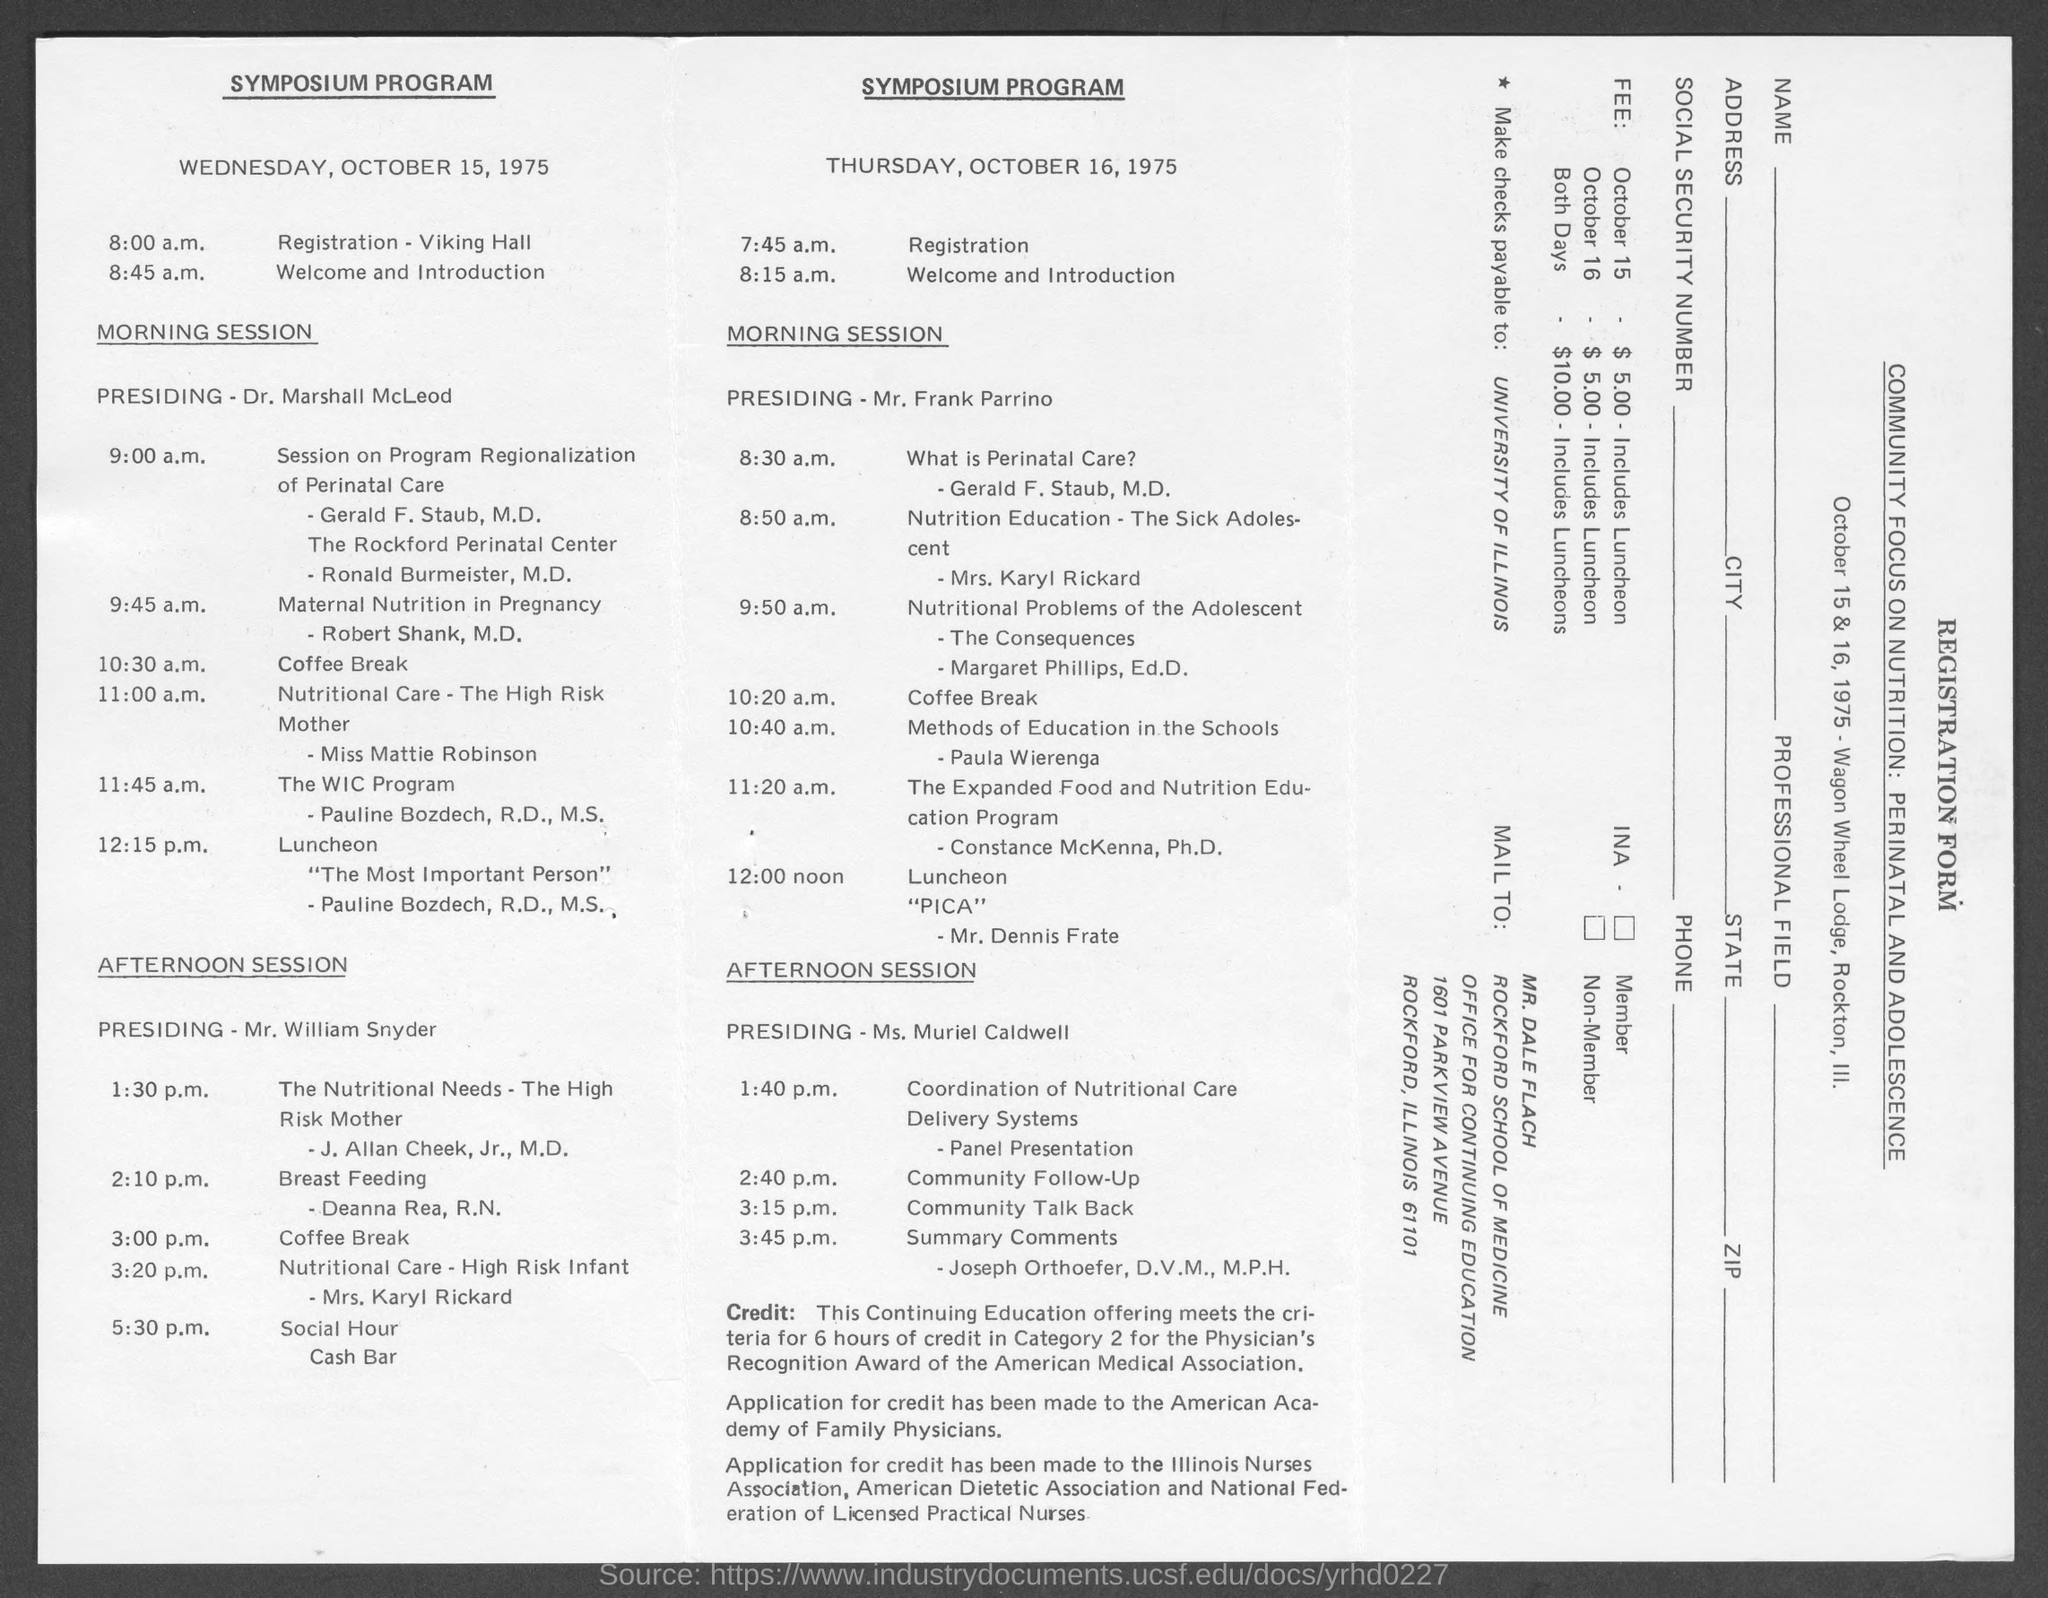When is the Registration on Wednesday, October 15, 1975?
Your response must be concise. 8:00 a.m. Where is the Registration on Wednesday, October 15, 1975?
Ensure brevity in your answer.  Viking Hall. When is the Registration on Thursday, October 16, 1975?
Your response must be concise. 7:45 a.m. When is the Welcome and Introduction on Wednesday, October 15, 1975?
Your answer should be compact. 8:45 a.m. When is the Welcome and Introduction on Thursday, October 16, 1975?
Your response must be concise. 8:15 a.m. Who is presiding the morning session on Wednesday, October 15, 1975?
Offer a terse response. Dr. Marshall McLeod. Who is presiding the morning session on Thursday, October 16, 1975?
Your answer should be very brief. Mr. Frank Parrino. Who is presiding the afternoon session on Thursday, October 16, 1975?
Your answer should be very brief. Ms. Muriel Caldwell. Who is presiding the afternoon session on Wednesday, October 15, 1975?
Your answer should be very brief. Mr. William Snyder. When is the summary comments on Thursday, October 16, 1975?
Your answer should be compact. 3:45 p.m. 